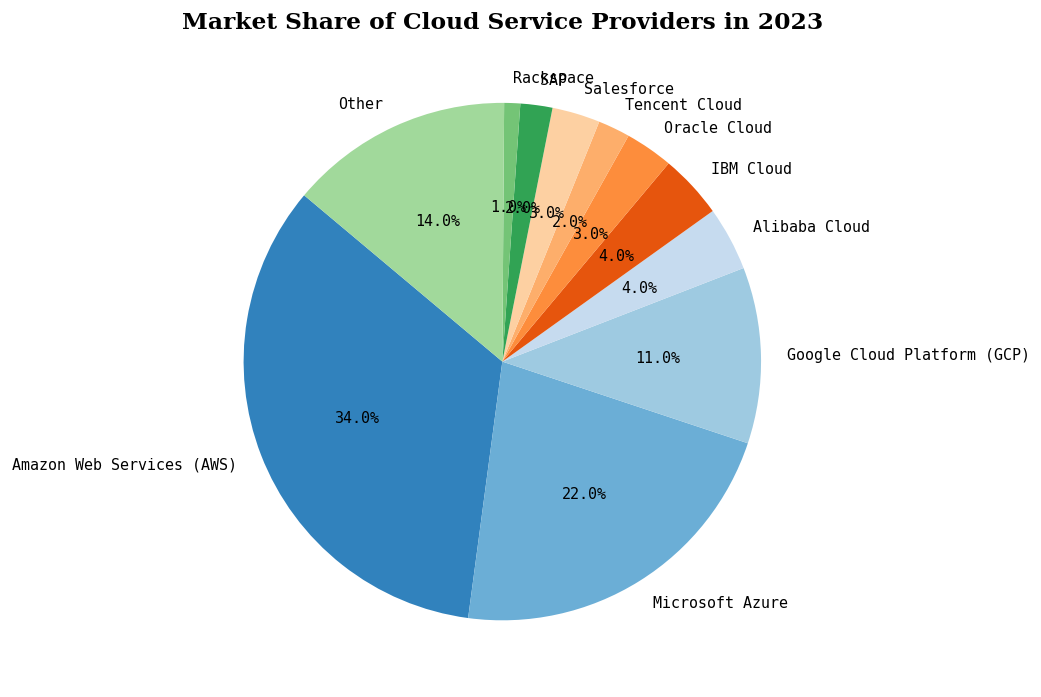What's the market share of IBM Cloud? The figure lists the market share for each cloud service provider. Look for IBM Cloud and note its percentage.
Answer: 4% What is the combined market share of Microsoft Azure and AWS? Sum the market shares of Microsoft Azure (22%) and AWS (34%). The combined market share is 22% + 34% = 56%.
Answer: 56% Which provider has the smallest market share, and what is it? By observing the pie chart, the smallest slice corresponds to Rackspace, which has a market share of 1%.
Answer: Rackspace, 1% How does the market share of Google Cloud Platform compare to Alibaba Cloud? The market share of Google Cloud Platform is 11%, while Alibaba Cloud has a 4% share. 11% is greater than 4%.
Answer: Greater What is the total market share of the providers with less than 3% market share individually? Identify providers with less than 3%: Tencent Cloud (2%), SAP (2%), and Rackspace (1%). Sum their shares: 2% + 2% + 1% = 5%.
Answer: 5% What is the difference in market share between Tencent Cloud and Salesforce? Subtract the market share of Tencent Cloud (2%) from Salesforce (3%): 3% - 2% = 1%.
Answer: 1% What is the visual color used to represent Microsoft Azure in the pie chart? The specific color for Microsoft Azure can be identified by observing its corresponding segment in the pie chart. It’s one of the colors from the color map used, specific in the chart provided by matplotlib's tab20c.
Answer: (For reference only, should match visual) Which providers have a market share that is equal to 4%? According to the figure, both IBM Cloud and Alibaba Cloud each have a market share of 4%.
Answer: IBM Cloud, Alibaba Cloud What is the market share of cloud providers other than AWS, Microsoft Azure, and Google Cloud Platform? Sum the market shares of all providers except AWS, Microsoft Azure, and Google Cloud Platform: 4% + 4% + 3% + 2% + 3% + 2% + 1% + 14% = 33%.
Answer: 33% By how much does the market share of AWS exceed the sum of Oracle Cloud and Salesforce? Oracle Cloud (3%) + Salesforce (3%) = 6%. AWS has a market share of 34%. Subtract the sum of Oracle and Salesforce from AWS: 34% - 6% = 28%.
Answer: 28% 